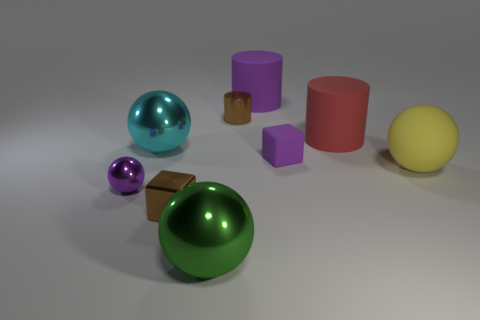What number of purple cylinders are the same size as the brown metal cylinder?
Keep it short and to the point. 0. What material is the large cyan object that is the same shape as the big green thing?
Offer a very short reply. Metal. There is a purple thing that is both right of the metal cylinder and in front of the cyan metallic sphere; what shape is it?
Keep it short and to the point. Cube. What is the shape of the purple object that is to the left of the cyan shiny thing?
Offer a very short reply. Sphere. What number of things are behind the big cyan thing and in front of the large purple thing?
Your answer should be very brief. 2. There is a purple cylinder; is it the same size as the brown shiny thing behind the large yellow matte ball?
Provide a short and direct response. No. There is a cube right of the cube to the left of the big thing that is in front of the tiny purple sphere; what size is it?
Make the answer very short. Small. What is the size of the cyan object that is behind the tiny purple shiny object?
Your answer should be compact. Large. What is the shape of the big yellow object that is the same material as the purple cylinder?
Give a very brief answer. Sphere. Do the large object that is behind the big red cylinder and the big red cylinder have the same material?
Offer a very short reply. Yes. 